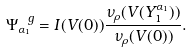<formula> <loc_0><loc_0><loc_500><loc_500>\Psi ^ { \ g } _ { \alpha _ { 1 } } = I ( V ( 0 ) ) \frac { \nu _ { \rho } ( V ( Y ^ { \alpha _ { 1 } } _ { 1 } ) ) } { \nu _ { \rho } ( V ( 0 ) ) } .</formula> 